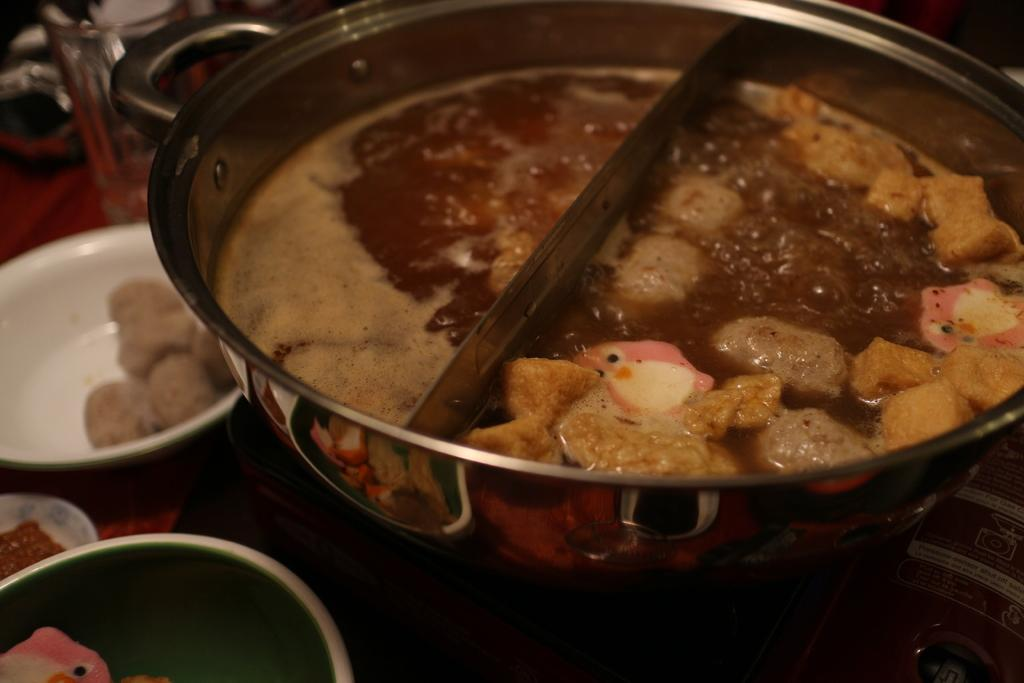What is in the bowl that is visible in the image? There are food items in a bowl in the image. Besides the bowl, what other objects can be seen in the image? There are other objects in the image, but their specific nature is not mentioned in the provided facts. Where are the utensils located in the image? The utensils are in the background of the image. What is the surface material of the area where the utensils are placed? The utensils are on a wooden surface. Can you tell me the scale of the map in the image? There is no map present in the image, so it is not possible to determine the scale of a map. 